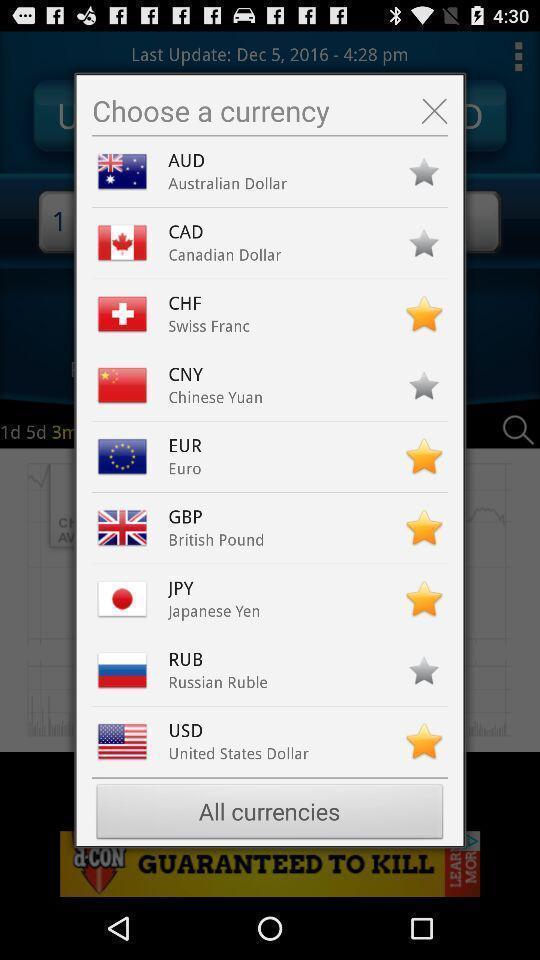Provide a description of this screenshot. Pop up to choose a currency from a list. 